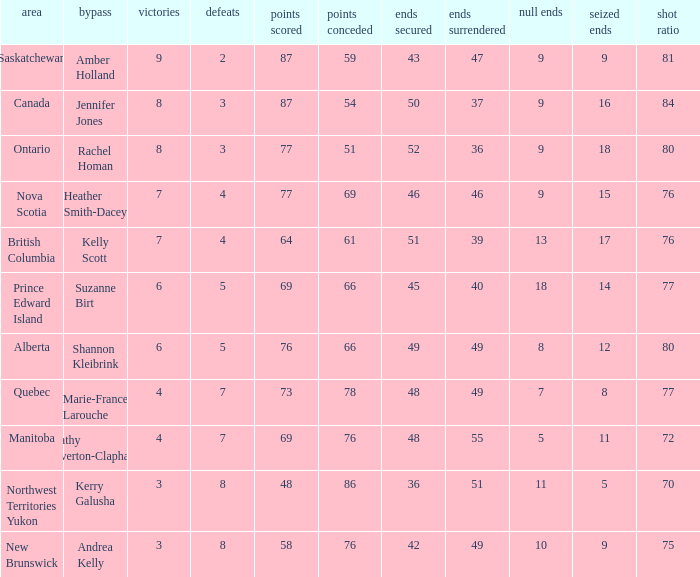If the skip is Kelly Scott, what is the PF total number? 1.0. 